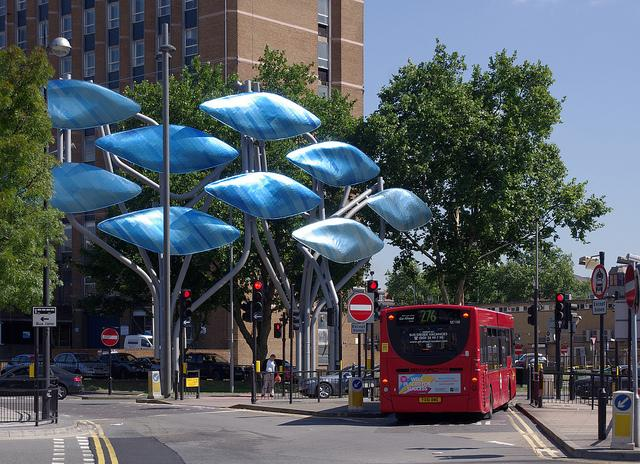What type of art is this? Please explain your reasoning. sculpture. Sculptures are normally three dimensional and often displayed in public. 